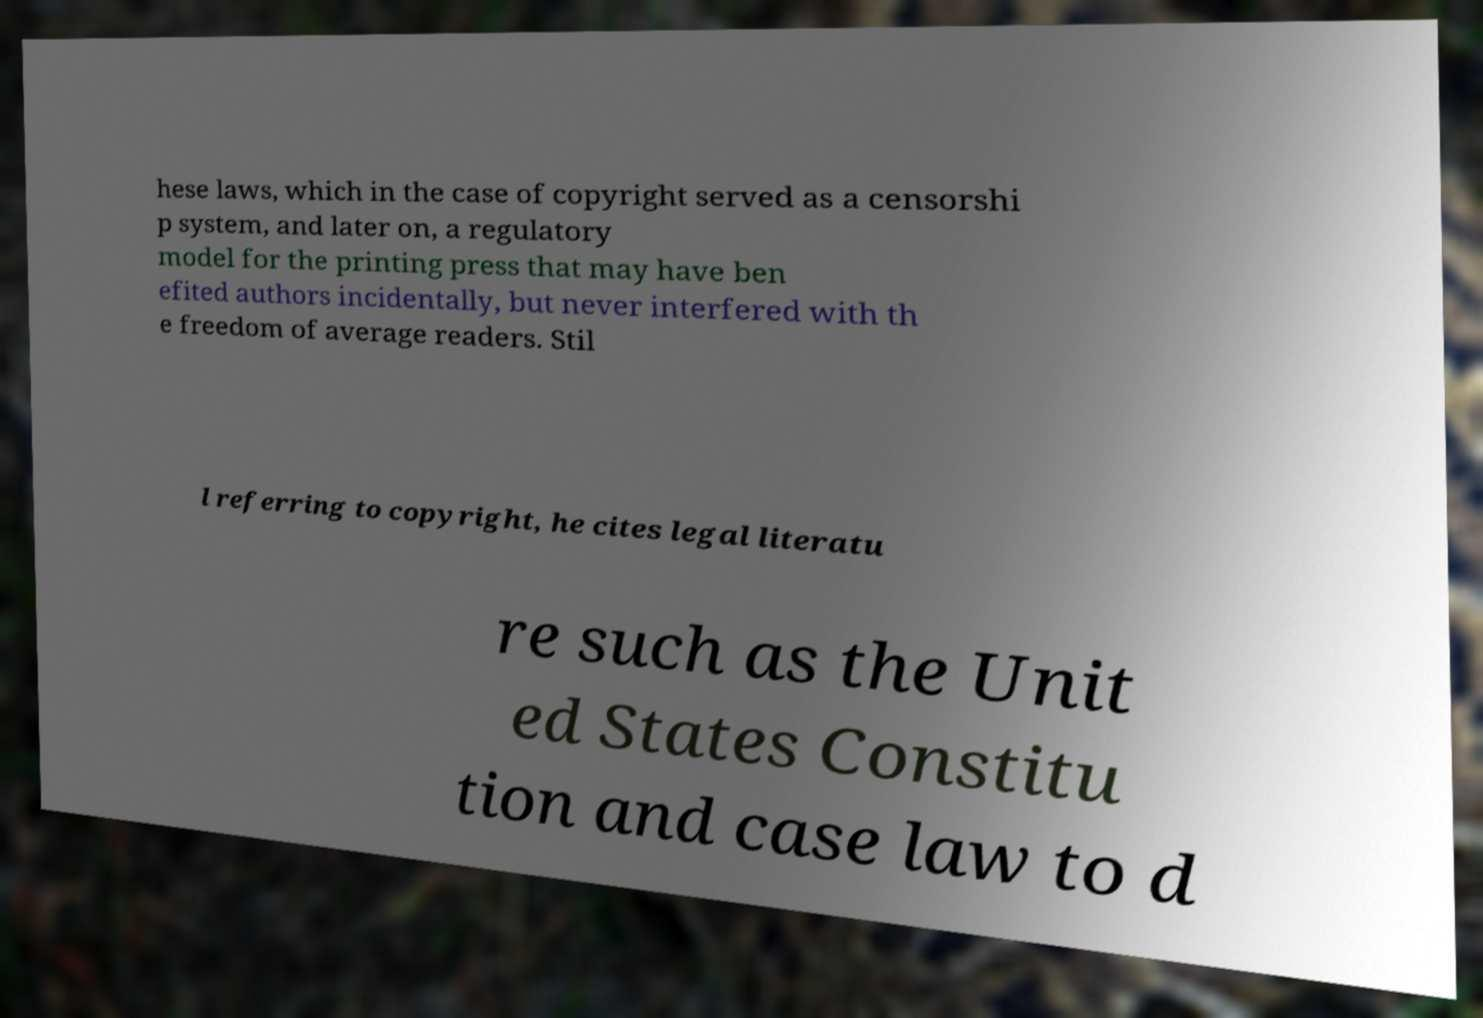What messages or text are displayed in this image? I need them in a readable, typed format. hese laws, which in the case of copyright served as a censorshi p system, and later on, a regulatory model for the printing press that may have ben efited authors incidentally, but never interfered with th e freedom of average readers. Stil l referring to copyright, he cites legal literatu re such as the Unit ed States Constitu tion and case law to d 